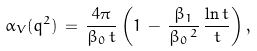<formula> <loc_0><loc_0><loc_500><loc_500>\alpha _ { V } ( { q } ^ { 2 } ) \, = \, \frac { 4 \pi } { \beta _ { 0 } \, t } \left ( 1 \, - \, \frac { \beta _ { 1 } } { \beta _ { 0 } \, ^ { 2 } } \, \frac { \ln t } { t } \right ) ,</formula> 